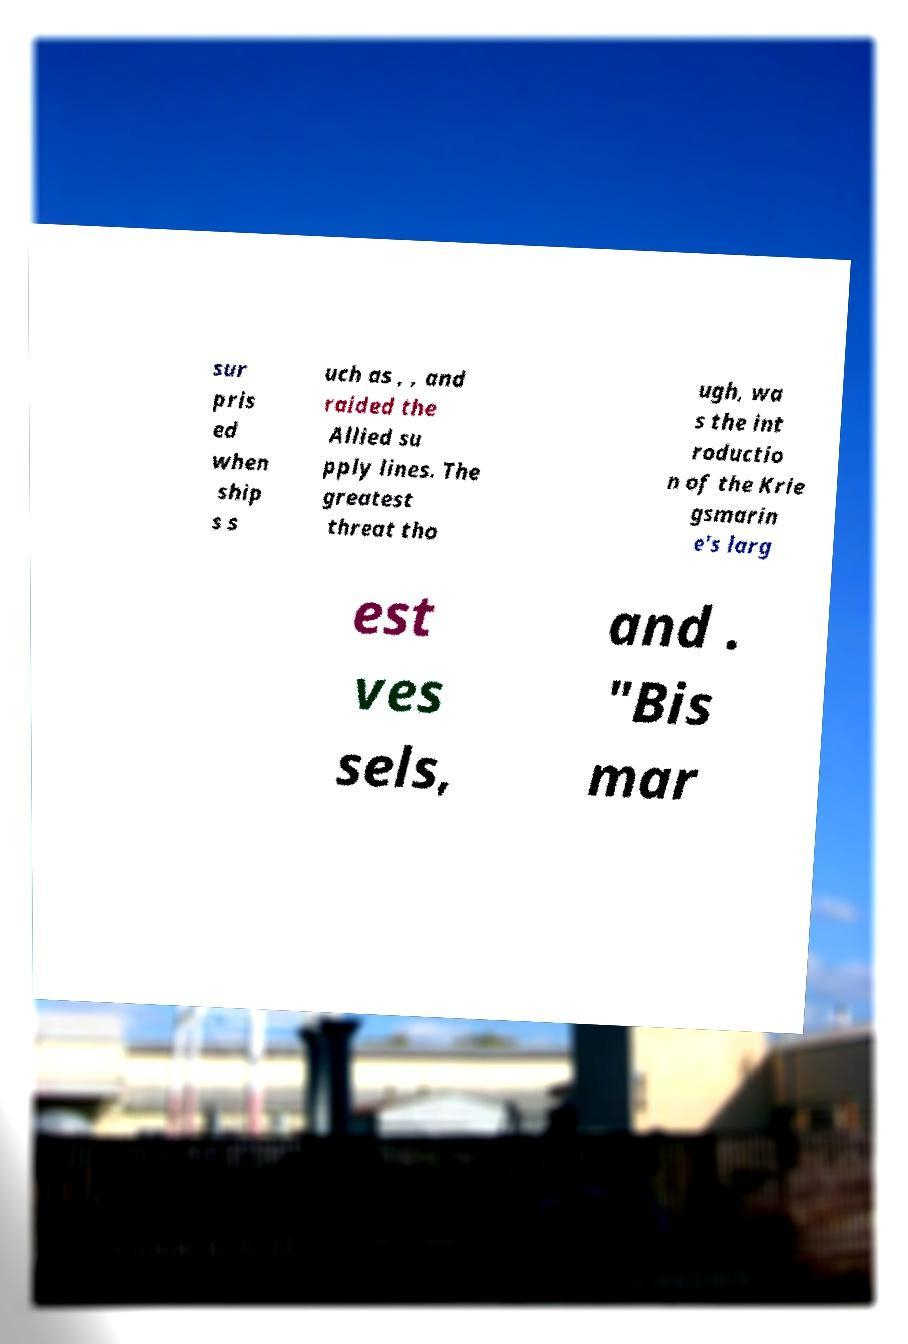For documentation purposes, I need the text within this image transcribed. Could you provide that? sur pris ed when ship s s uch as , , and raided the Allied su pply lines. The greatest threat tho ugh, wa s the int roductio n of the Krie gsmarin e's larg est ves sels, and . "Bis mar 